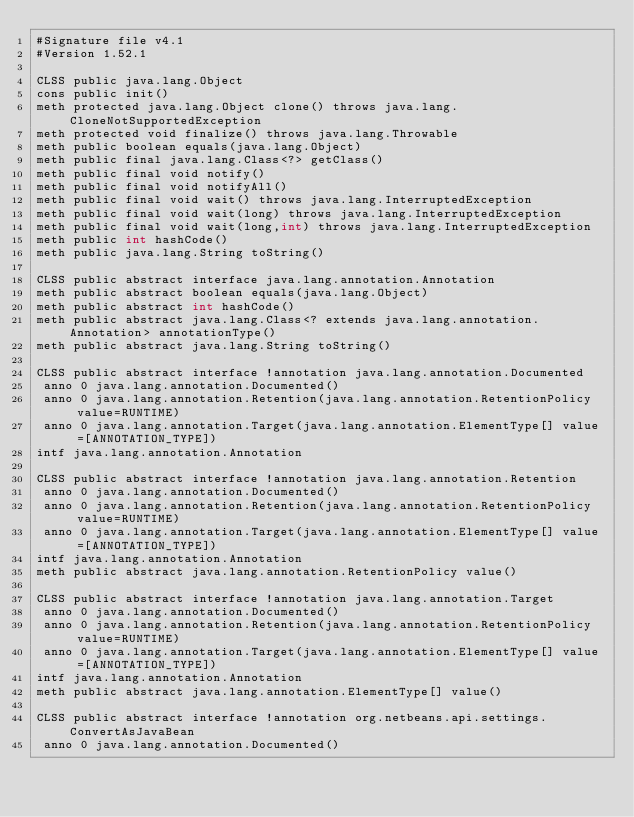<code> <loc_0><loc_0><loc_500><loc_500><_SML_>#Signature file v4.1
#Version 1.52.1

CLSS public java.lang.Object
cons public init()
meth protected java.lang.Object clone() throws java.lang.CloneNotSupportedException
meth protected void finalize() throws java.lang.Throwable
meth public boolean equals(java.lang.Object)
meth public final java.lang.Class<?> getClass()
meth public final void notify()
meth public final void notifyAll()
meth public final void wait() throws java.lang.InterruptedException
meth public final void wait(long) throws java.lang.InterruptedException
meth public final void wait(long,int) throws java.lang.InterruptedException
meth public int hashCode()
meth public java.lang.String toString()

CLSS public abstract interface java.lang.annotation.Annotation
meth public abstract boolean equals(java.lang.Object)
meth public abstract int hashCode()
meth public abstract java.lang.Class<? extends java.lang.annotation.Annotation> annotationType()
meth public abstract java.lang.String toString()

CLSS public abstract interface !annotation java.lang.annotation.Documented
 anno 0 java.lang.annotation.Documented()
 anno 0 java.lang.annotation.Retention(java.lang.annotation.RetentionPolicy value=RUNTIME)
 anno 0 java.lang.annotation.Target(java.lang.annotation.ElementType[] value=[ANNOTATION_TYPE])
intf java.lang.annotation.Annotation

CLSS public abstract interface !annotation java.lang.annotation.Retention
 anno 0 java.lang.annotation.Documented()
 anno 0 java.lang.annotation.Retention(java.lang.annotation.RetentionPolicy value=RUNTIME)
 anno 0 java.lang.annotation.Target(java.lang.annotation.ElementType[] value=[ANNOTATION_TYPE])
intf java.lang.annotation.Annotation
meth public abstract java.lang.annotation.RetentionPolicy value()

CLSS public abstract interface !annotation java.lang.annotation.Target
 anno 0 java.lang.annotation.Documented()
 anno 0 java.lang.annotation.Retention(java.lang.annotation.RetentionPolicy value=RUNTIME)
 anno 0 java.lang.annotation.Target(java.lang.annotation.ElementType[] value=[ANNOTATION_TYPE])
intf java.lang.annotation.Annotation
meth public abstract java.lang.annotation.ElementType[] value()

CLSS public abstract interface !annotation org.netbeans.api.settings.ConvertAsJavaBean
 anno 0 java.lang.annotation.Documented()</code> 